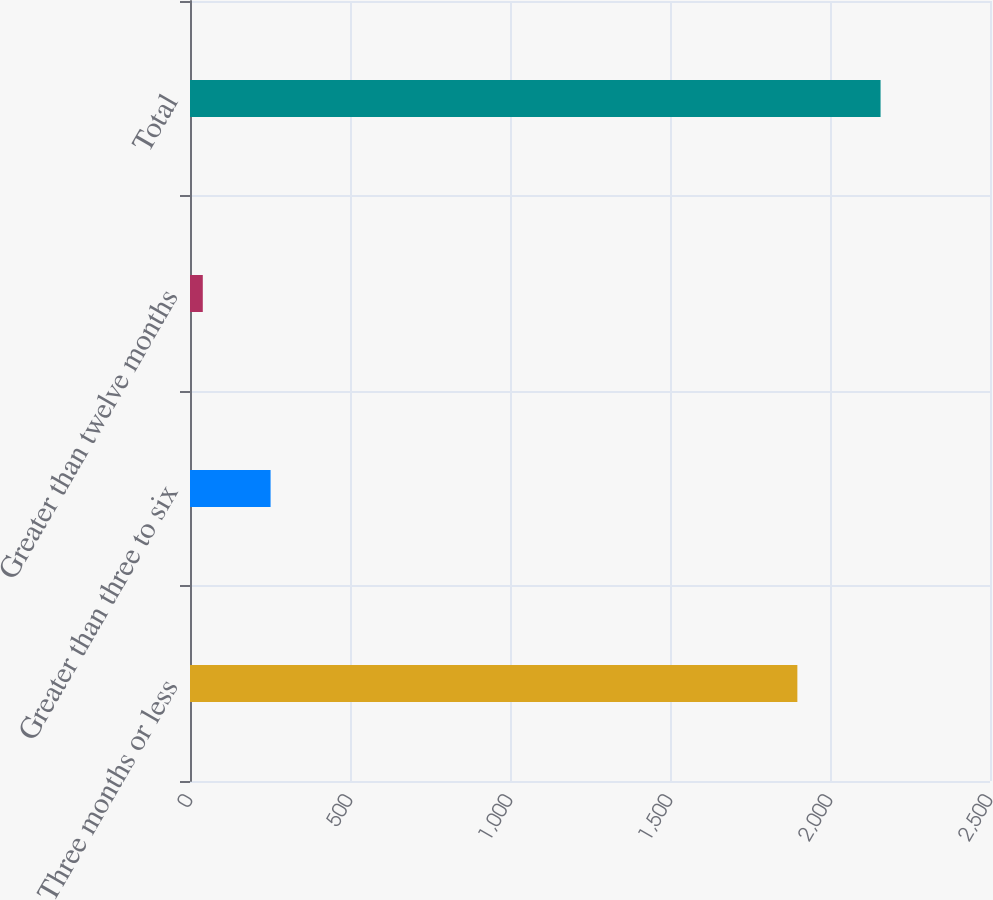<chart> <loc_0><loc_0><loc_500><loc_500><bar_chart><fcel>Three months or less<fcel>Greater than three to six<fcel>Greater than twelve months<fcel>Total<nl><fcel>1898<fcel>251.8<fcel>40<fcel>2158<nl></chart> 